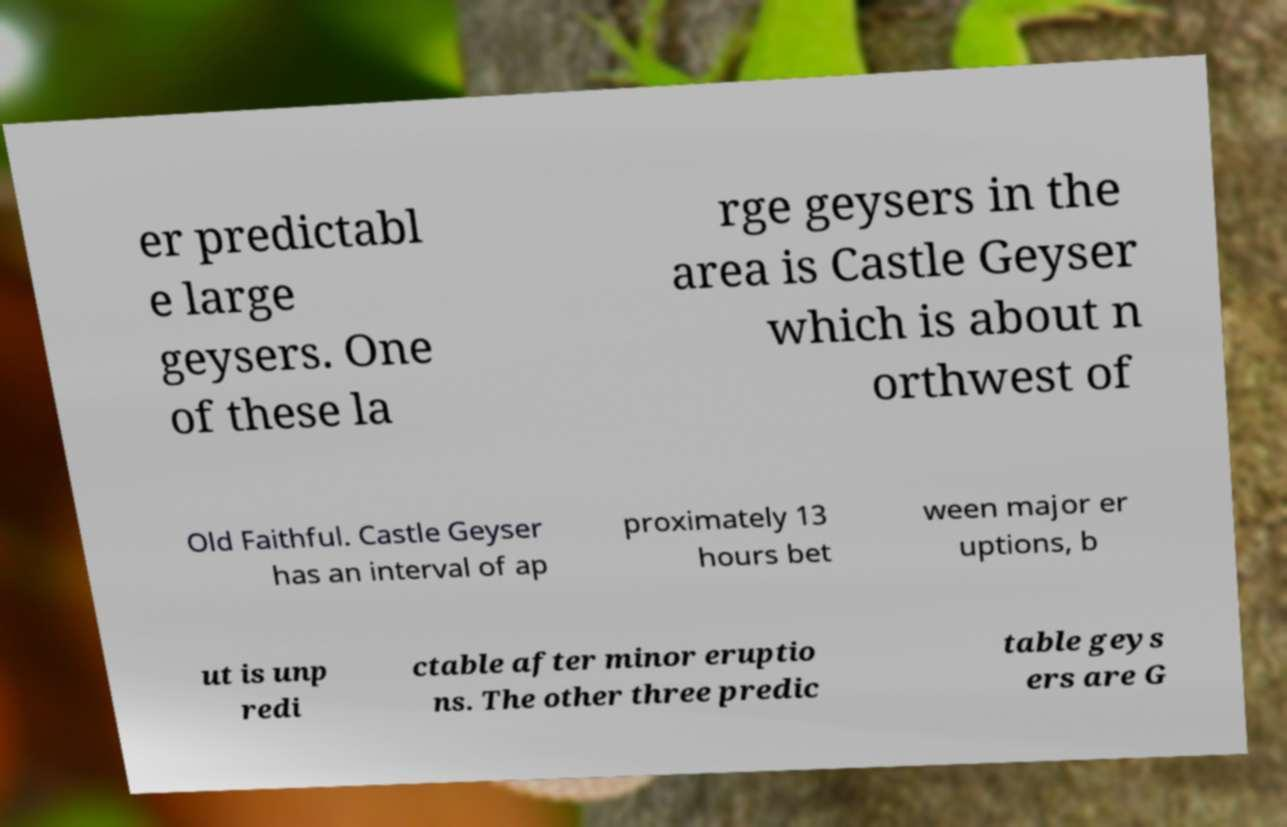Could you extract and type out the text from this image? er predictabl e large geysers. One of these la rge geysers in the area is Castle Geyser which is about n orthwest of Old Faithful. Castle Geyser has an interval of ap proximately 13 hours bet ween major er uptions, b ut is unp redi ctable after minor eruptio ns. The other three predic table geys ers are G 